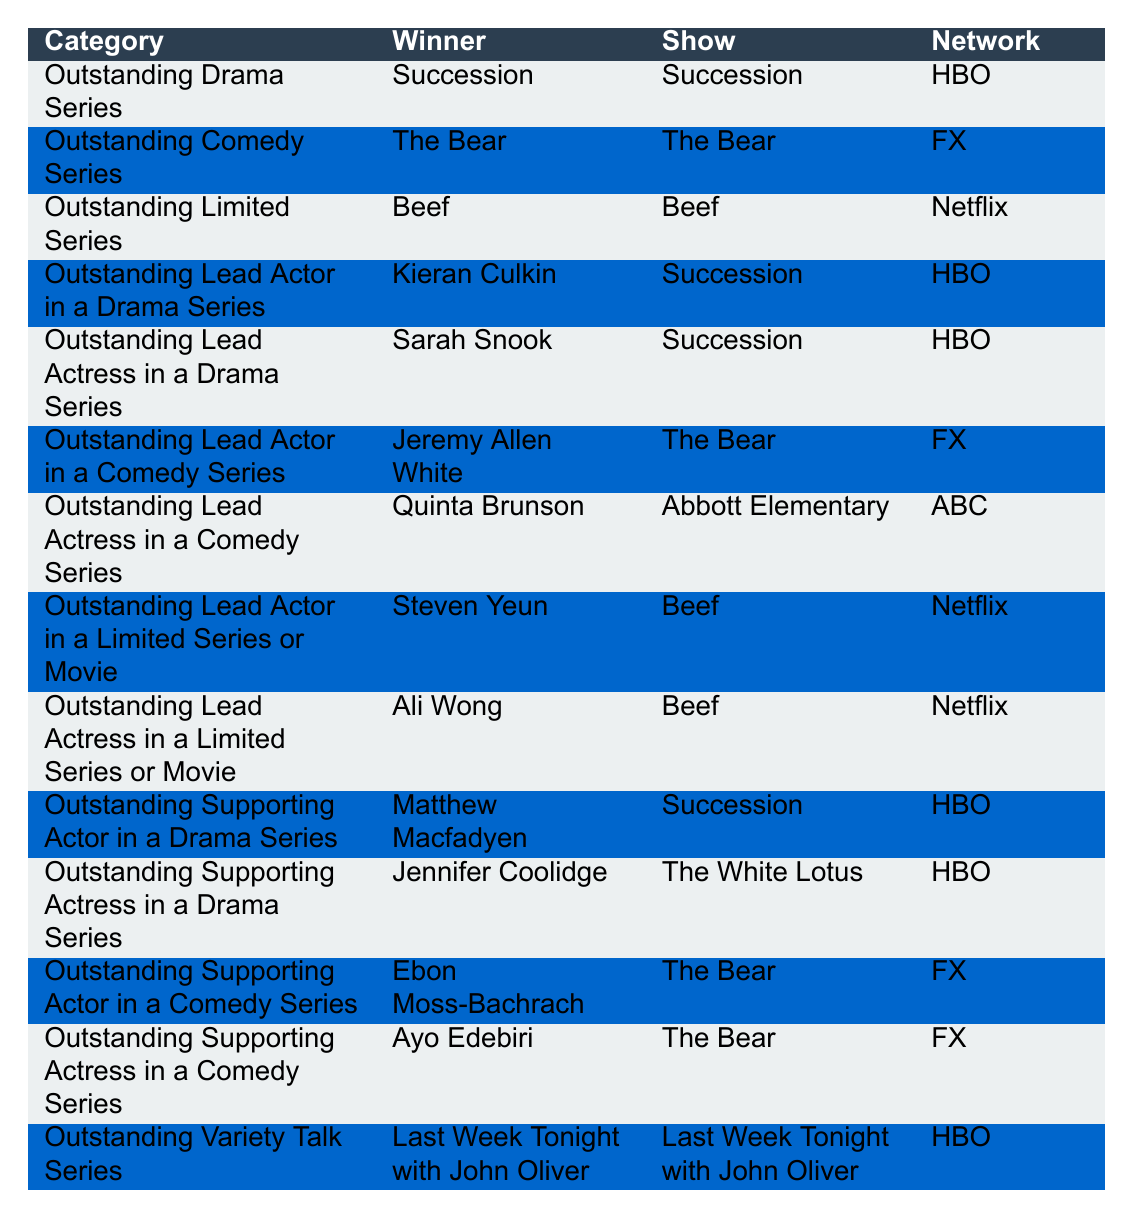What show won the Outstanding Drama Series? The table indicates that "Succession" won the Outstanding Drama Series.
Answer: Succession Who is the winner of the Outstanding Lead Actress in a Comedy Series? According to the table, the winner for this category is Quinta Brunson.
Answer: Quinta Brunson Which network broadcast the show that won Outstanding Limited Series? The data shows that "Beef," which won Outstanding Limited Series, was on Netflix.
Answer: Netflix How many categories did "The Bear" win awards in? The table shows "The Bear" won awards for Outstanding Comedy Series, Outstanding Lead Actor in a Comedy Series, Outstanding Supporting Actor in a Comedy Series, and Outstanding Supporting Actress in a Comedy Series. This totals to 4 categories.
Answer: 4 Did Kieran Culkin win for a comedy or a drama series? Kieran Culkin won for Outstanding Lead Actor in a Drama Series, indicating he was recognized in the drama category.
Answer: Drama Which show had the most wins in total? The table shows "Succession" won 4 awards (Outstanding Drama Series, Outstanding Lead Actor, Outstanding Lead Actress, Outstanding Supporting Actor), whereas "The Bear" won 4 as well (Outstanding Comedy Series, Outstanding Lead Actor, Outstanding Supporting Actor, Outstanding Supporting Actress), but no other show won as many. So, both "Succession" and "The Bear" tied for most wins.
Answer: Tied (Succession & The Bear) Is there any actress from "Beef" who won an award? The table indicates that both Ali Wong and Steven Yeun, who starred in "Beef," won awards, specifically in the Limited Series or Movie categories.
Answer: Yes How many awards did HBO win? The table shows HBO winning in Outstanding Drama Series, Outstanding Lead Actor in a Drama Series, Outstanding Lead Actress in a Drama Series, Outstanding Supporting Actor in a Drama Series, Outstanding Supporting Actress in a Drama Series, and Outstanding Variety Talk Series, adding up to 6 awards.
Answer: 6 What is the only network that has a show winning Outstanding Lead Actor in a Limited Series or Movie? The table specifies that "Beef," aired on Netflix, and Steven Yeun won for this category. Therefore, Netflix is the only network represented here for that specific award.
Answer: Netflix Who were the two lead actors in "Succession"? The data shows that Kieran Culkin and Sarah Snook were recognized in the lead actor categories for "Succession."
Answer: Kieran Culkin, Sarah Snook 